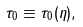Convert formula to latex. <formula><loc_0><loc_0><loc_500><loc_500>\tau _ { 0 } \equiv \tau _ { 0 } ( \eta ) ,</formula> 